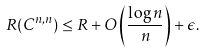<formula> <loc_0><loc_0><loc_500><loc_500>R ( C ^ { n , n } ) \leq R + O \left ( \frac { \log n } { n } \right ) + \epsilon .</formula> 